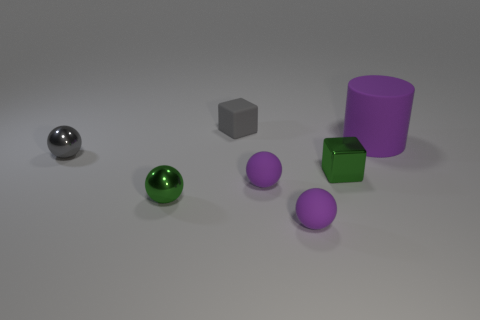Does the tiny gray matte object have the same shape as the green shiny object to the right of the green ball?
Keep it short and to the point. Yes. There is another matte block that is the same size as the green cube; what color is it?
Provide a succinct answer. Gray. Are there fewer tiny gray things to the left of the small gray metallic object than small purple balls on the right side of the tiny green metallic cube?
Ensure brevity in your answer.  No. What shape is the purple thing behind the cube right of the small object that is behind the purple cylinder?
Your answer should be compact. Cylinder. Is the color of the block behind the large purple rubber thing the same as the small block in front of the big matte cylinder?
Offer a very short reply. No. How many metal things are tiny green balls or tiny spheres?
Provide a short and direct response. 2. There is a small block that is behind the small gray thing that is in front of the purple thing behind the tiny gray ball; what is its color?
Provide a succinct answer. Gray. Is there any other thing of the same color as the metal block?
Offer a very short reply. Yes. How many other things are there of the same material as the big cylinder?
Your answer should be very brief. 3. The purple cylinder has what size?
Offer a very short reply. Large. 